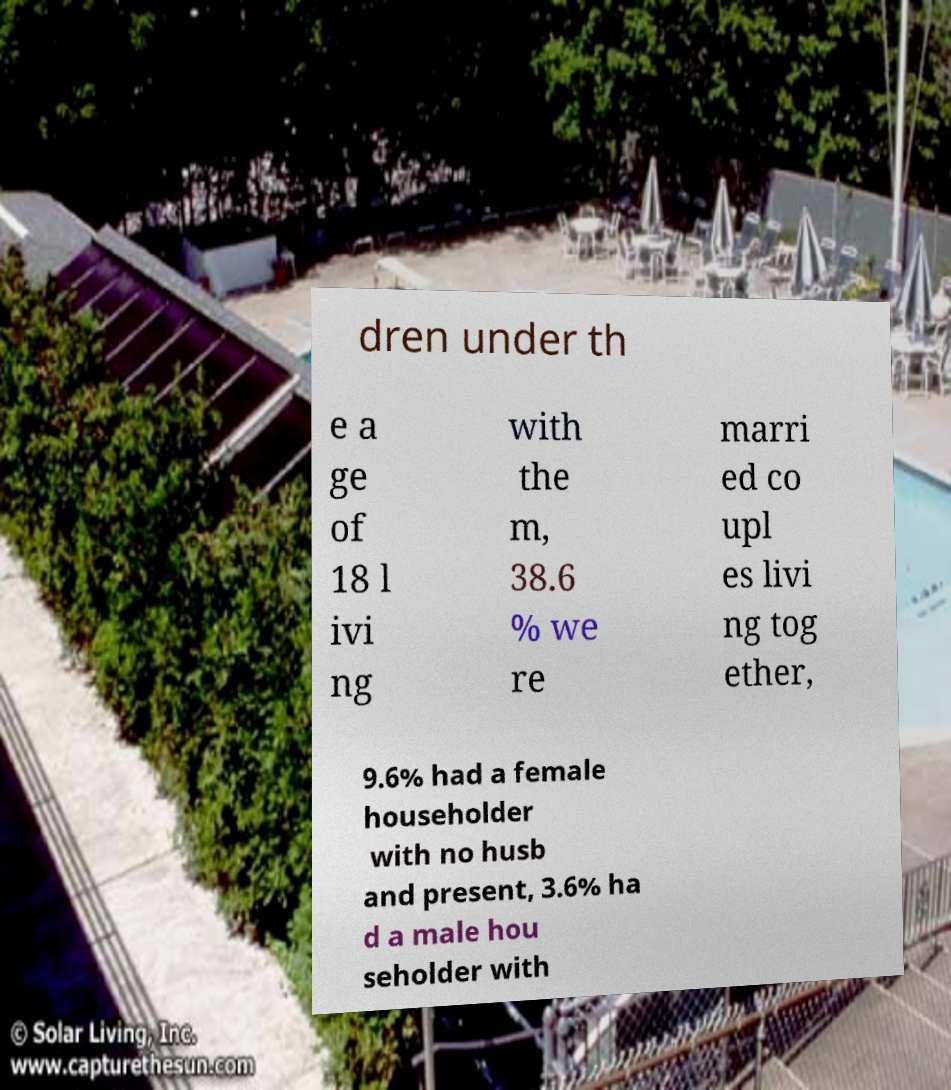I need the written content from this picture converted into text. Can you do that? dren under th e a ge of 18 l ivi ng with the m, 38.6 % we re marri ed co upl es livi ng tog ether, 9.6% had a female householder with no husb and present, 3.6% ha d a male hou seholder with 